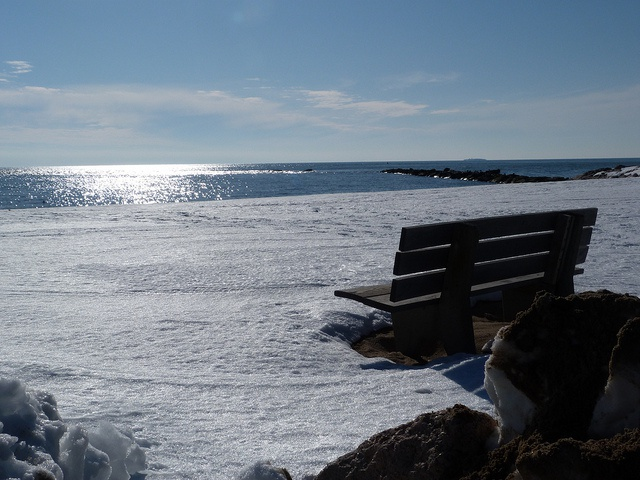Describe the objects in this image and their specific colors. I can see a bench in gray, black, and darkgray tones in this image. 